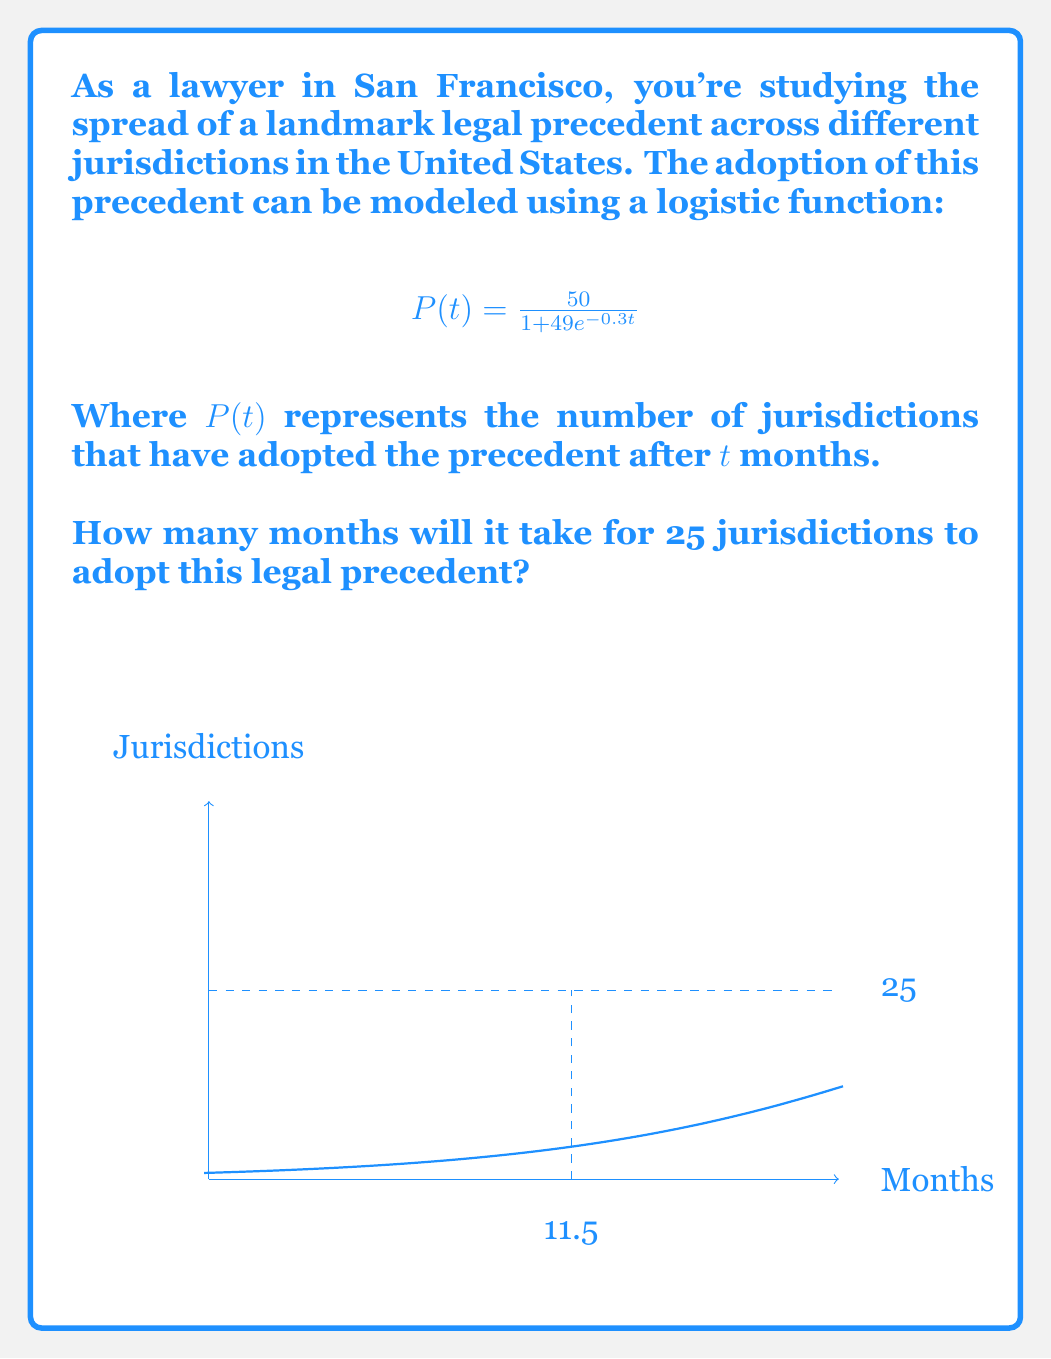Provide a solution to this math problem. Let's approach this step-by-step:

1) We need to find $t$ when $P(t) = 25$. This gives us the equation:

   $$25 = \frac{50}{1 + 49e^{-0.3t}}$$

2) Multiply both sides by the denominator:

   $$25(1 + 49e^{-0.3t}) = 50$$

3) Distribute on the left side:

   $$25 + 1225e^{-0.3t} = 50$$

4) Subtract 25 from both sides:

   $$1225e^{-0.3t} = 25$$

5) Divide both sides by 1225:

   $$e^{-0.3t} = \frac{25}{1225} = \frac{1}{49}$$

6) Take the natural log of both sides:

   $$-0.3t = \ln(\frac{1}{49})$$

7) Divide both sides by -0.3:

   $$t = -\frac{\ln(\frac{1}{49})}{0.3}$$

8) Simplify:

   $$t = \frac{\ln(49)}{0.3} \approx 11.5$$

Therefore, it will take approximately 11.5 months for 25 jurisdictions to adopt this legal precedent.
Answer: 11.5 months 